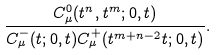Convert formula to latex. <formula><loc_0><loc_0><loc_500><loc_500>\frac { C ^ { 0 } _ { \mu } ( t ^ { n } , t ^ { m } ; 0 , t ) } { C ^ { - } _ { \mu } ( t ; 0 , t ) C ^ { + } _ { \mu } ( t ^ { m + n - 2 } t ; 0 , t ) } .</formula> 